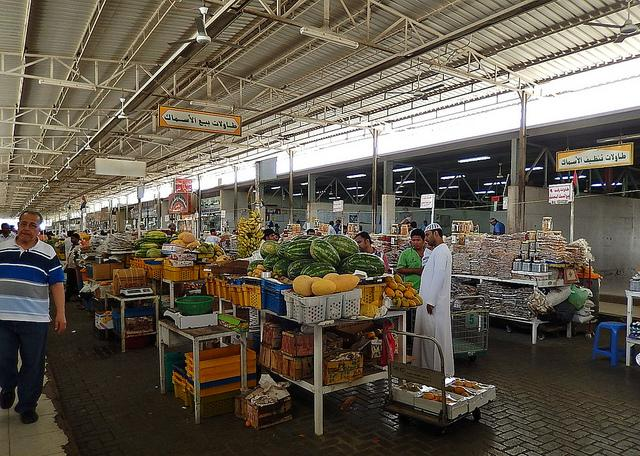What part of the market is located here? produce 